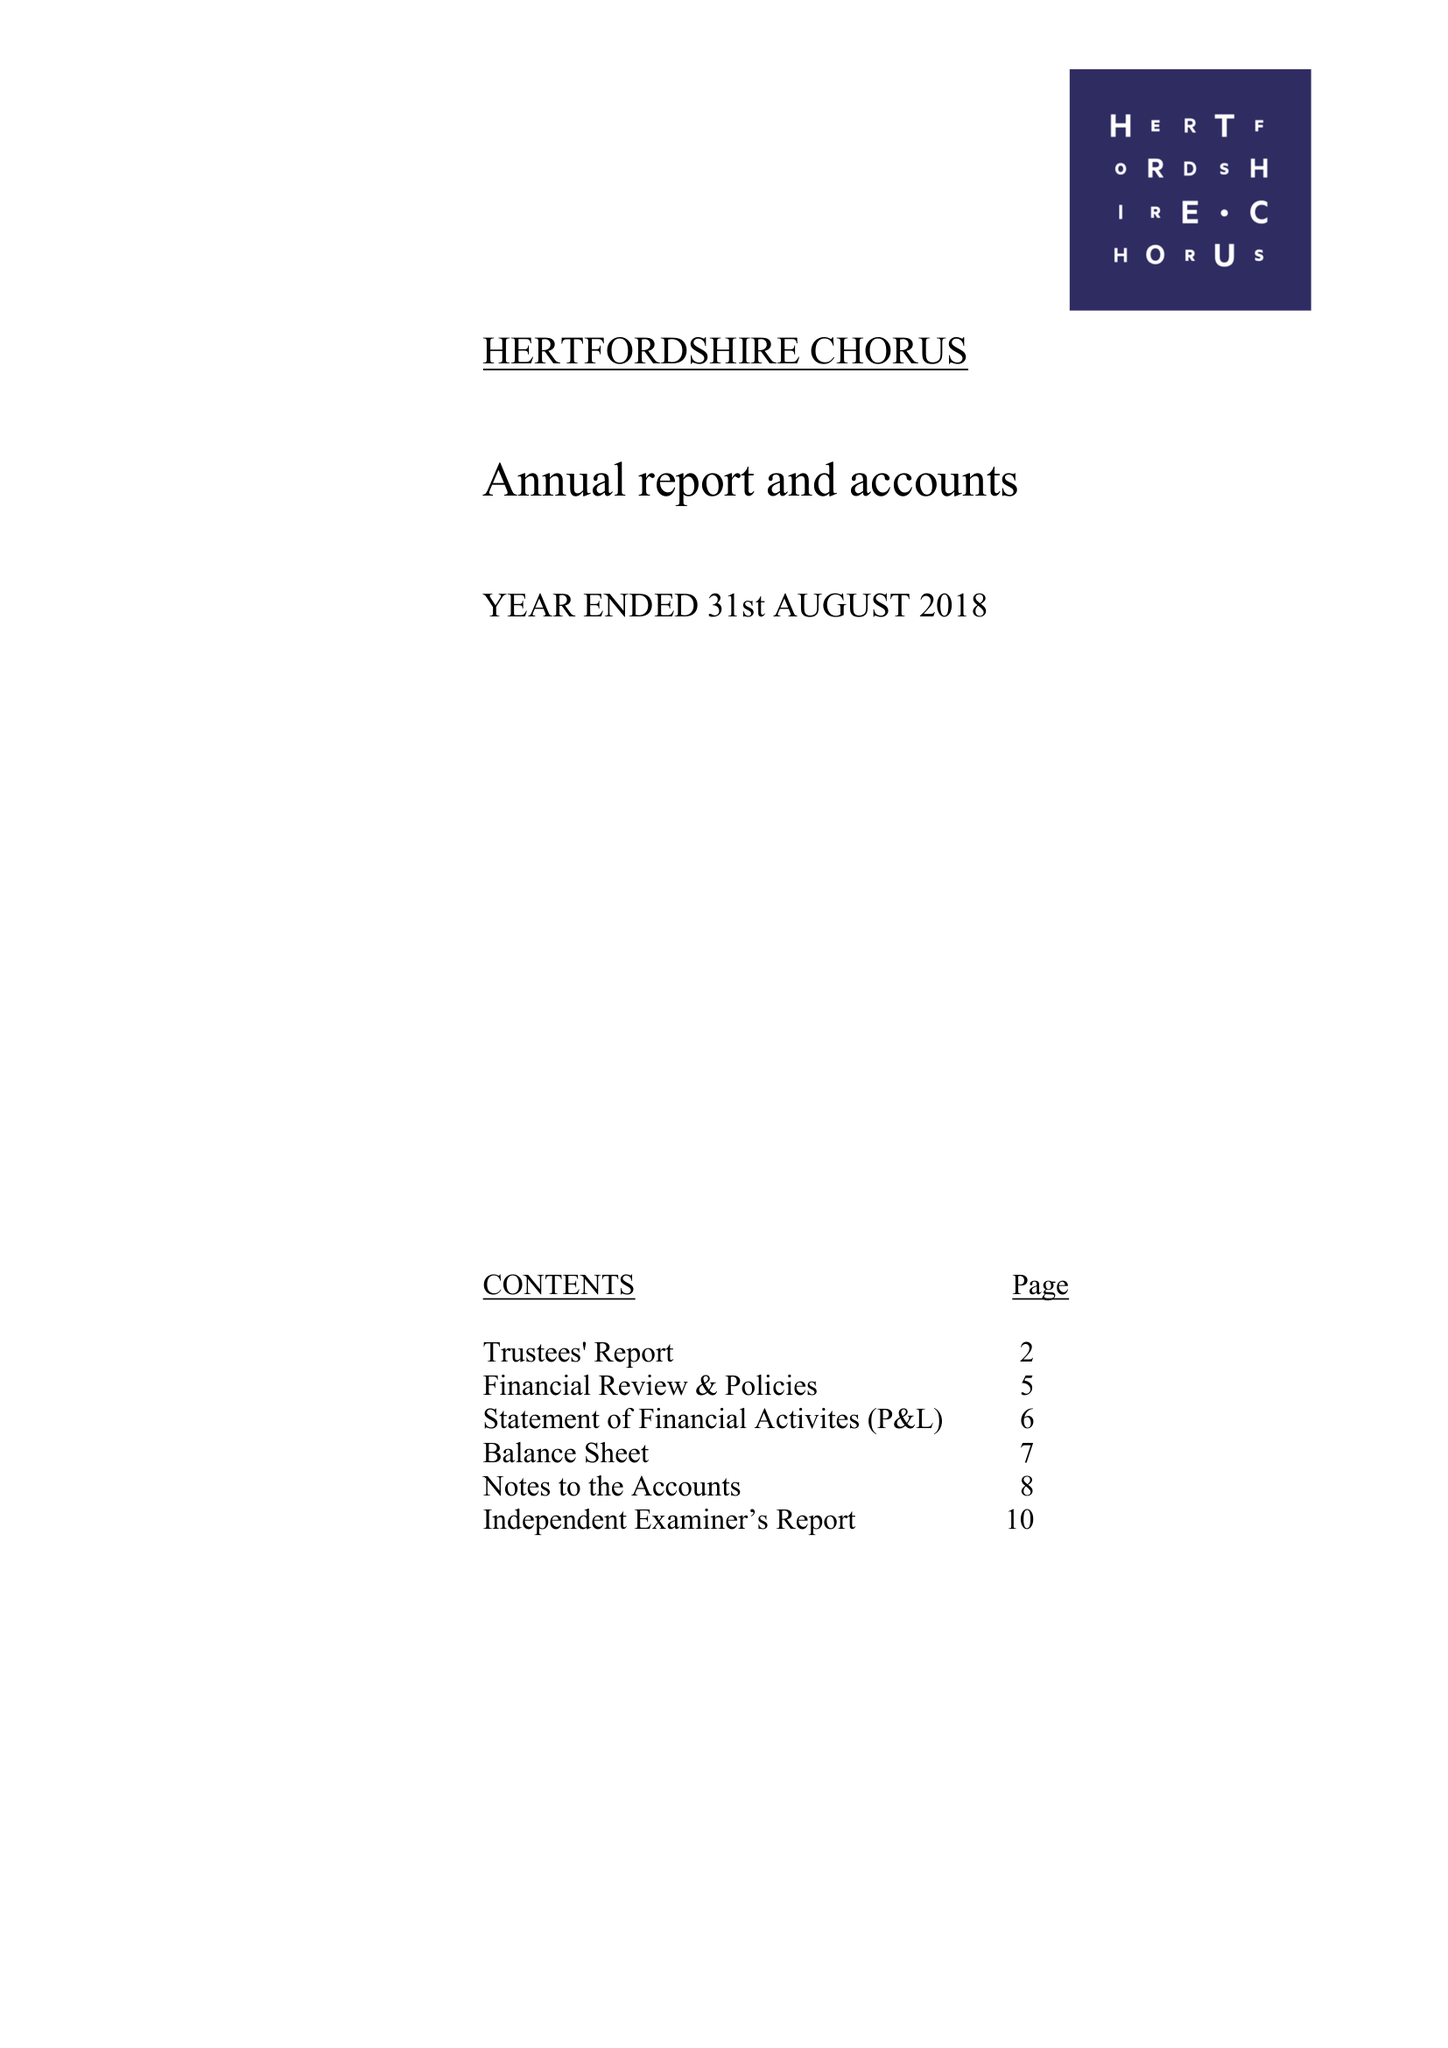What is the value for the income_annually_in_british_pounds?
Answer the question using a single word or phrase. 104608.00 